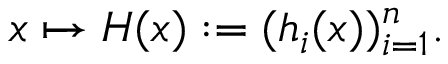Convert formula to latex. <formula><loc_0><loc_0><loc_500><loc_500>x \mapsto H ( x ) \colon = ( h _ { i } ( x ) ) _ { i = 1 } ^ { n } .</formula> 